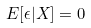<formula> <loc_0><loc_0><loc_500><loc_500>E [ \epsilon | X ] = 0</formula> 